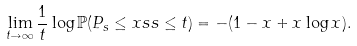<formula> <loc_0><loc_0><loc_500><loc_500>& \lim _ { t \to \infty } \frac { 1 } { t } \log \mathbb { P } ( P _ { s } \leq x s s \leq t ) = - ( 1 - x + x \log x ) .</formula> 